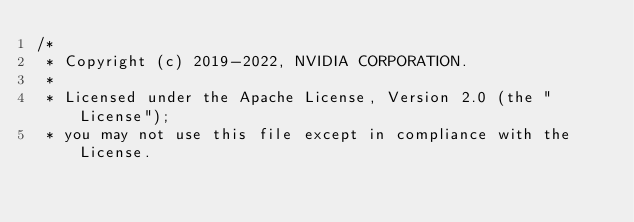Convert code to text. <code><loc_0><loc_0><loc_500><loc_500><_Cuda_>/*
 * Copyright (c) 2019-2022, NVIDIA CORPORATION.
 *
 * Licensed under the Apache License, Version 2.0 (the "License");
 * you may not use this file except in compliance with the License.</code> 